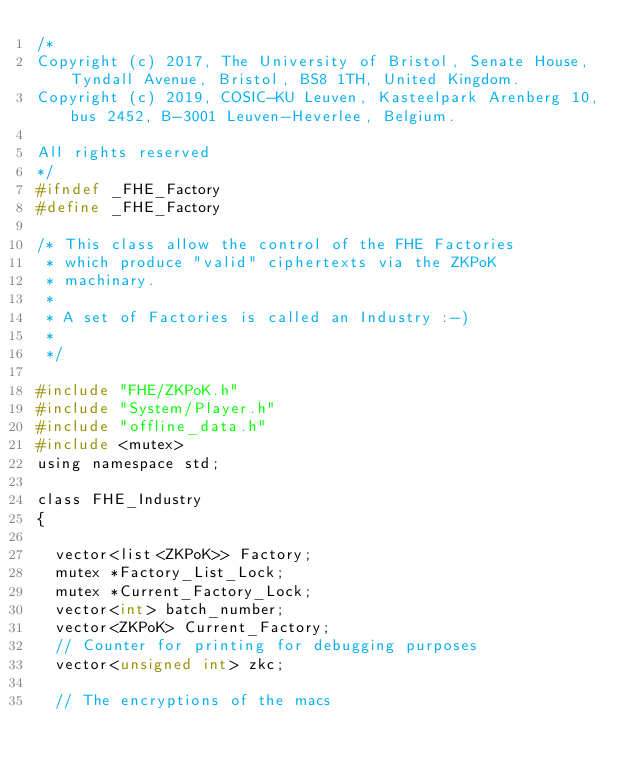Convert code to text. <code><loc_0><loc_0><loc_500><loc_500><_C_>/*
Copyright (c) 2017, The University of Bristol, Senate House, Tyndall Avenue, Bristol, BS8 1TH, United Kingdom.
Copyright (c) 2019, COSIC-KU Leuven, Kasteelpark Arenberg 10, bus 2452, B-3001 Leuven-Heverlee, Belgium.

All rights reserved
*/
#ifndef _FHE_Factory
#define _FHE_Factory

/* This class allow the control of the FHE Factories
 * which produce "valid" ciphertexts via the ZKPoK
 * machinary.
 *
 * A set of Factories is called an Industry :-)
 *
 */

#include "FHE/ZKPoK.h"
#include "System/Player.h"
#include "offline_data.h"
#include <mutex>
using namespace std;

class FHE_Industry
{

  vector<list<ZKPoK>> Factory;
  mutex *Factory_List_Lock;
  mutex *Current_Factory_Lock;
  vector<int> batch_number;
  vector<ZKPoK> Current_Factory;
  // Counter for printing for debugging purposes
  vector<unsigned int> zkc;

  // The encryptions of the macs</code> 